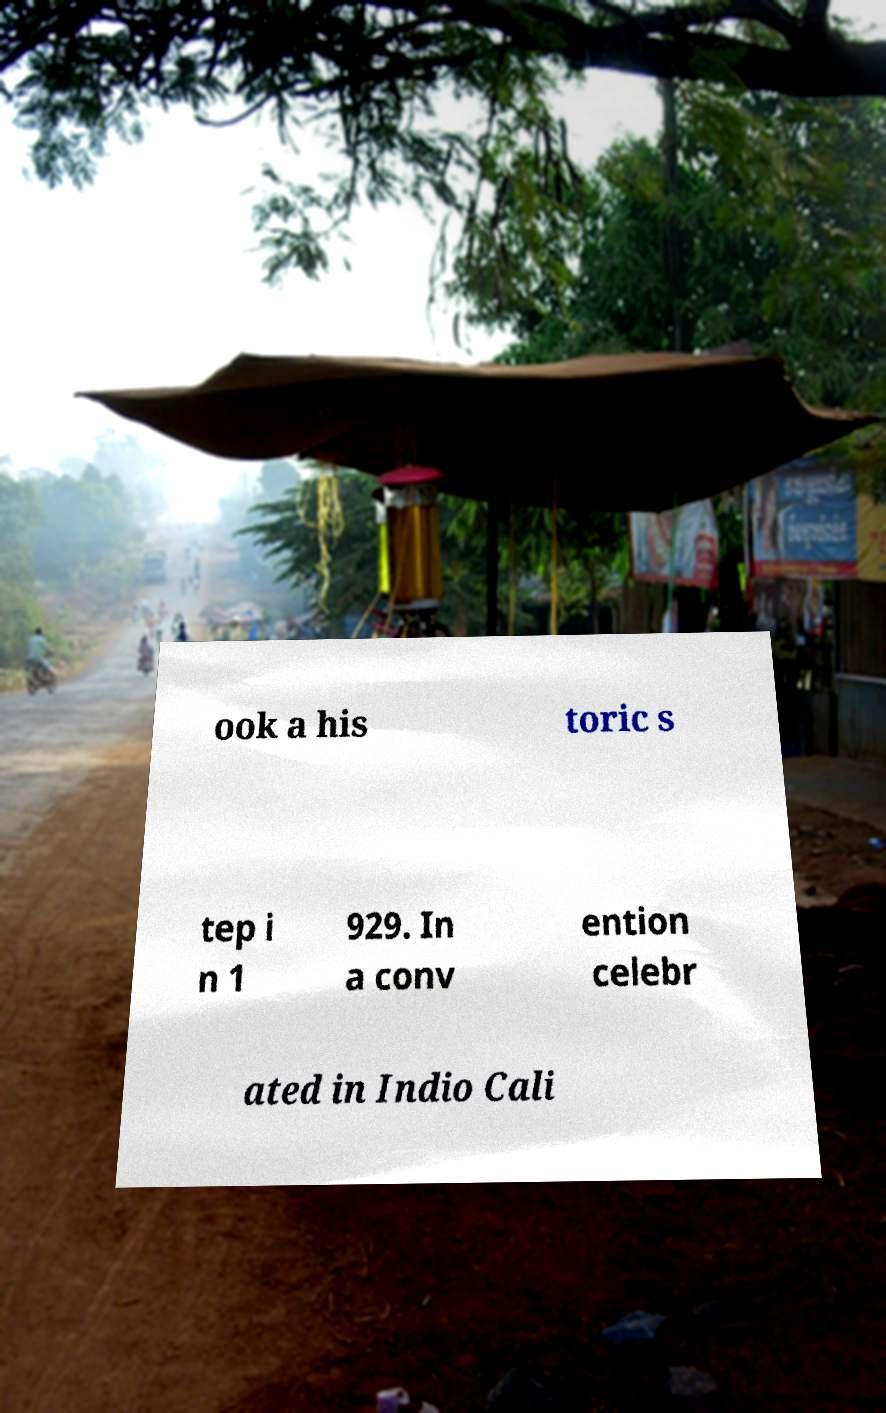Can you accurately transcribe the text from the provided image for me? ook a his toric s tep i n 1 929. In a conv ention celebr ated in Indio Cali 